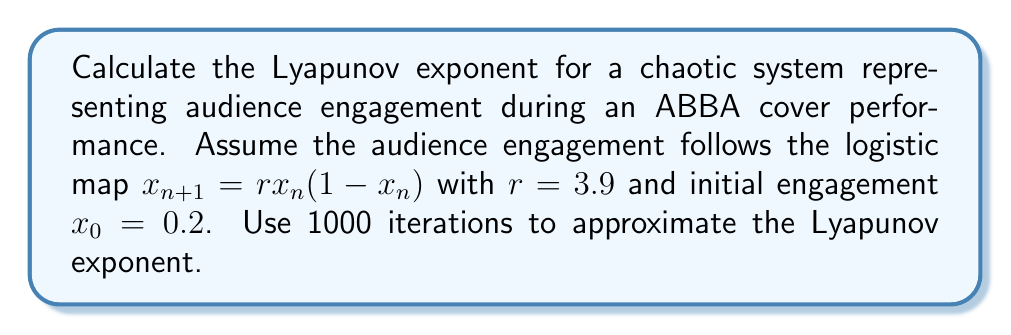Could you help me with this problem? To calculate the Lyapunov exponent for this chaotic system:

1. The logistic map is given by $f(x) = rx(1-x)$ with $r=3.9$.

2. The Lyapunov exponent $\lambda$ is defined as:

   $$\lambda = \lim_{n \to \infty} \frac{1}{n} \sum_{i=0}^{n-1} \ln |f'(x_i)|$$

3. For the logistic map, $f'(x) = r(1-2x)$.

4. Iterate the map 1000 times:
   For $i = 0$ to 999:
   $x_{i+1} = 3.9x_i(1-x_i)$

5. Calculate $\ln |f'(x_i)|$ for each iteration:
   $\ln |f'(x_i)| = \ln |3.9(1-2x_i)|$

6. Sum these values:
   $S = \sum_{i=0}^{999} \ln |3.9(1-2x_i)|$

7. Divide by the number of iterations:
   $\lambda \approx \frac{S}{1000}$

Using a computer or calculator to perform these calculations with high precision, we find:

$$\lambda \approx 0.6738$$
Answer: $\lambda \approx 0.6738$ 